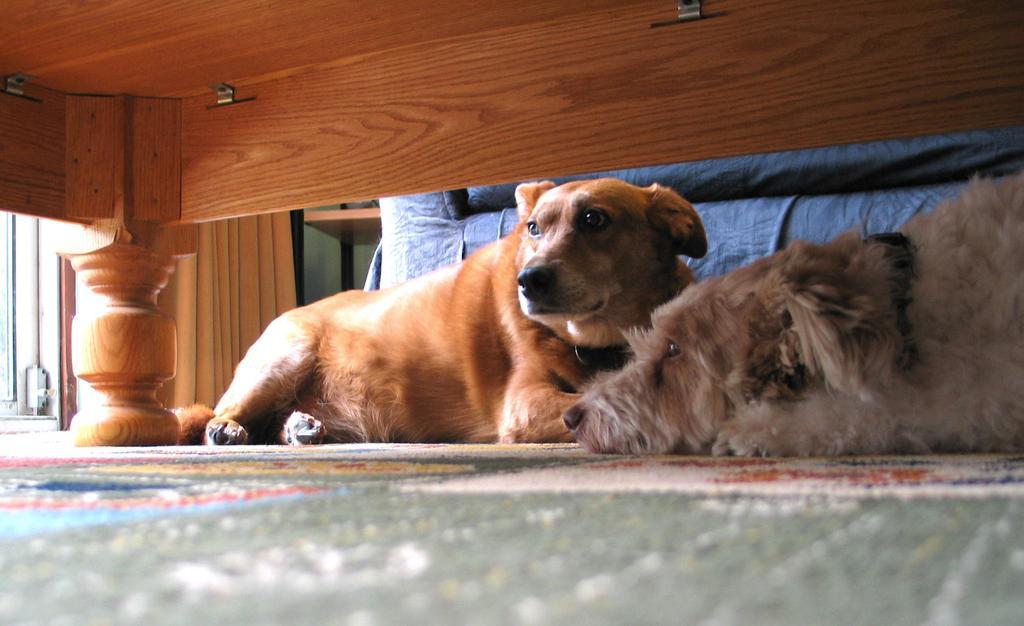Describe this image in one or two sentences. In this image we can see two dogs on the carpet. There is a wooden bed. 